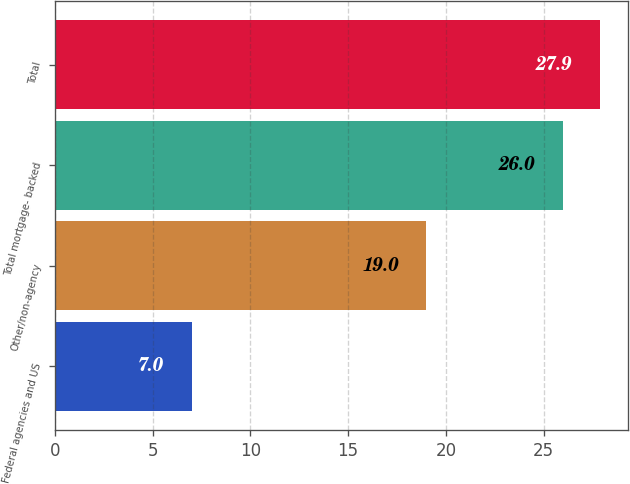<chart> <loc_0><loc_0><loc_500><loc_500><bar_chart><fcel>Federal agencies and US<fcel>Other/non-agency<fcel>Total mortgage- backed<fcel>Total<nl><fcel>7<fcel>19<fcel>26<fcel>27.9<nl></chart> 